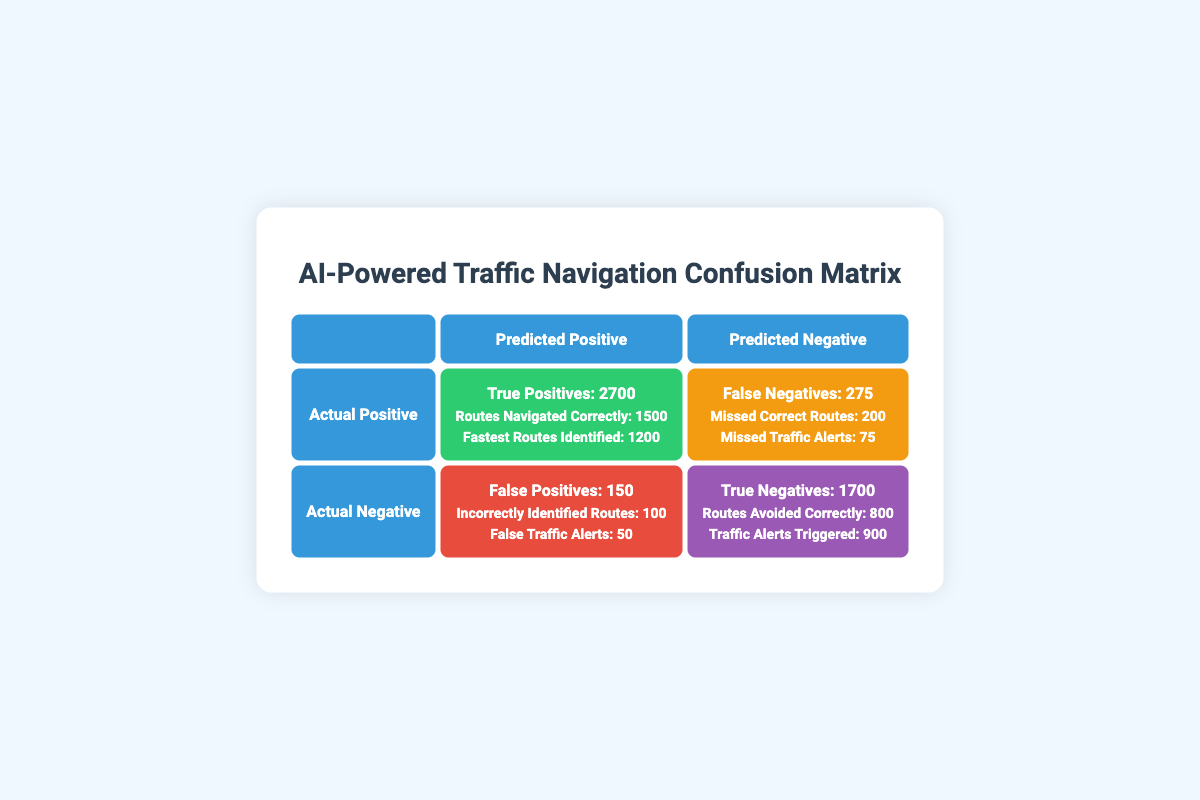What is the total number of True Positives? The table shows two categories under True Positives: Routes Navigated Correctly (1500) and Fastest Routes Identified (1200). To calculate the total True Positives, add these two values together: 1500 + 1200 = 2700.
Answer: 2700 How many False Positives are there for Incorrectly Identified Routes? The table provides the value for False Positives, which states there are 100 Incorrectly Identified Routes. Therefore, the answer is simply found in the data of the table.
Answer: 100 Are there more True Negatives than True Positives? The total True Negatives is 1700, while the total True Positives is 2700 (as calculated previously). Since 1700 is less than 2700, the answer is no.
Answer: No What percentage of the total alerts (True Negatives + False Positives) are False Positives? First, calculate the total alerts: True Negatives (1700) + False Positives (150), which equals 1850. Then, to find the percentage of False Positives (150) out of the total alerts (1850), use the formula: (150 / 1850) * 100 = 8.11%.
Answer: 8.11% What is the total number of missed alerts (False Negatives)? The table shows that False Negatives consist of two components: Missed Correct Routes (200) and Missed Traffic Alerts (75). To find the total missed alerts, add these values: 200 + 75 = 275.
Answer: 275 How many more correctly identified routes are there compared to incorrectly identified routes? From the table, we have 1500 correctly identified routes (True Positives) and 100 incorrectly identified routes (False Positives). To find the difference, subtract the value of incorrectly identified routes from correctly identified ones: 1500 - 100 = 1400.
Answer: 1400 Are there more missed traffic alerts than False Positives? The table states that False Positives include 50 False Traffic Alerts. Comparatively, there are 75 missed traffic alerts (False Negatives). Since 75 is greater than 50, the answer is yes.
Answer: Yes What is the combined total of all True and False Positives? The total for True Positives is 2700 (calculated earlier). The total for False Positives is 150. To find the combined total, add these two numbers together: 2700 + 150 = 2850.
Answer: 2850 What proportion of actual positives are correctly navigated routes? Actual positives include True Positives (2700) and False Negatives (275). The proportion of correctly navigated routes (1500) out of total positives (2700) is calculated as: 1500 / 2700 = 0.555.
Answer: 0.555 